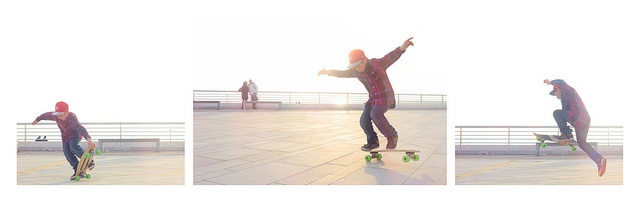Describe the objects in this image and their specific colors. I can see people in white, gray, brown, tan, and darkgray tones, people in white and gray tones, people in white, gray, and darkgray tones, skateboard in white, tan, gray, and darkgray tones, and skateboard in white, olive, tan, gray, and darkgray tones in this image. 